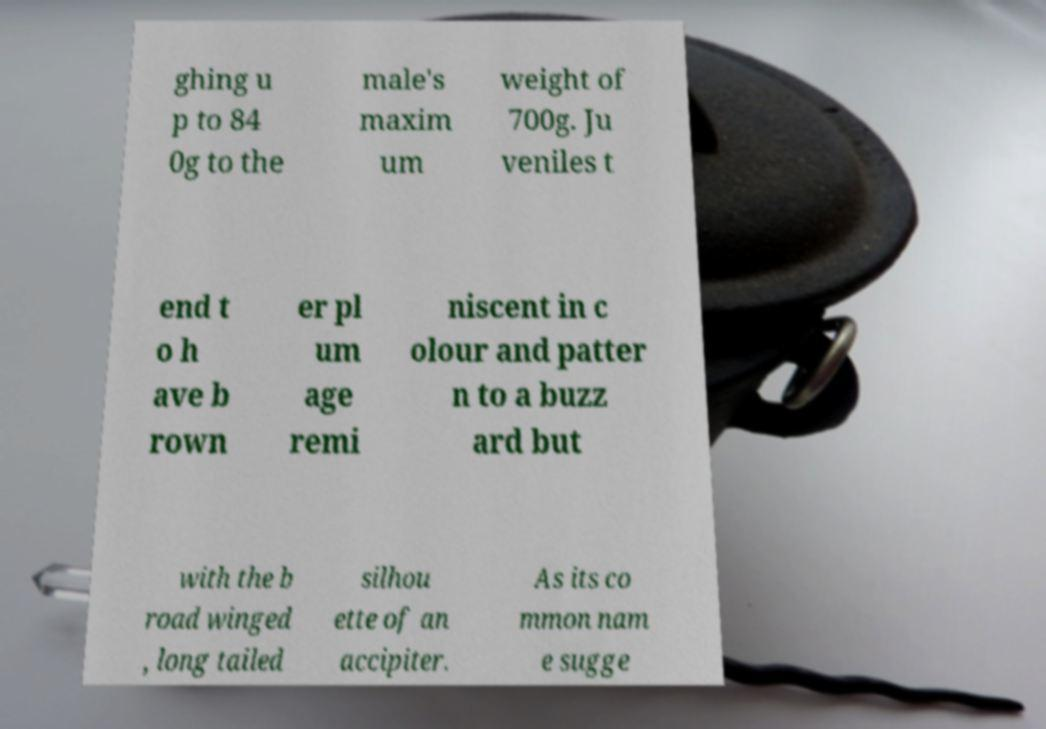For documentation purposes, I need the text within this image transcribed. Could you provide that? ghing u p to 84 0g to the male's maxim um weight of 700g. Ju veniles t end t o h ave b rown er pl um age remi niscent in c olour and patter n to a buzz ard but with the b road winged , long tailed silhou ette of an accipiter. As its co mmon nam e sugge 